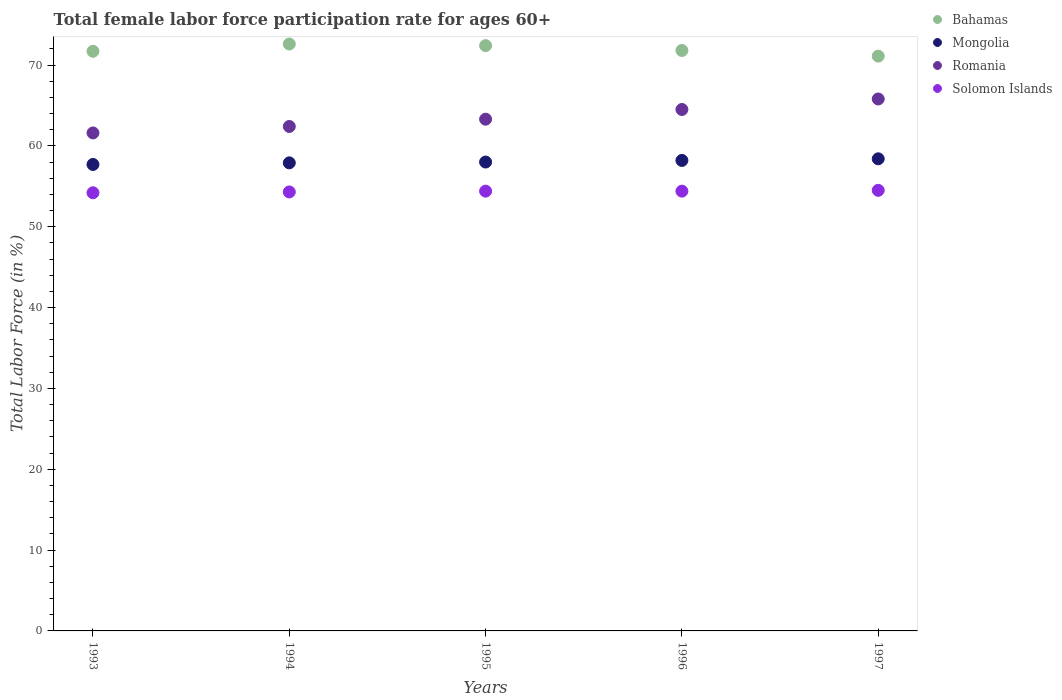How many different coloured dotlines are there?
Keep it short and to the point. 4. What is the female labor force participation rate in Mongolia in 1994?
Your answer should be compact. 57.9. Across all years, what is the maximum female labor force participation rate in Mongolia?
Offer a terse response. 58.4. Across all years, what is the minimum female labor force participation rate in Romania?
Your answer should be very brief. 61.6. What is the total female labor force participation rate in Solomon Islands in the graph?
Ensure brevity in your answer.  271.8. What is the difference between the female labor force participation rate in Romania in 1994 and that in 1997?
Your answer should be very brief. -3.4. What is the difference between the female labor force participation rate in Bahamas in 1994 and the female labor force participation rate in Solomon Islands in 1996?
Ensure brevity in your answer.  18.2. What is the average female labor force participation rate in Romania per year?
Provide a succinct answer. 63.52. In the year 1993, what is the difference between the female labor force participation rate in Romania and female labor force participation rate in Bahamas?
Provide a succinct answer. -10.1. In how many years, is the female labor force participation rate in Mongolia greater than 60 %?
Give a very brief answer. 0. What is the ratio of the female labor force participation rate in Mongolia in 1994 to that in 1995?
Keep it short and to the point. 1. Is the female labor force participation rate in Bahamas in 1993 less than that in 1994?
Give a very brief answer. Yes. Is the difference between the female labor force participation rate in Romania in 1996 and 1997 greater than the difference between the female labor force participation rate in Bahamas in 1996 and 1997?
Keep it short and to the point. No. What is the difference between the highest and the second highest female labor force participation rate in Mongolia?
Provide a succinct answer. 0.2. What is the difference between the highest and the lowest female labor force participation rate in Solomon Islands?
Keep it short and to the point. 0.3. Is the sum of the female labor force participation rate in Bahamas in 1993 and 1996 greater than the maximum female labor force participation rate in Mongolia across all years?
Make the answer very short. Yes. Is it the case that in every year, the sum of the female labor force participation rate in Solomon Islands and female labor force participation rate in Romania  is greater than the sum of female labor force participation rate in Mongolia and female labor force participation rate in Bahamas?
Make the answer very short. No. Is it the case that in every year, the sum of the female labor force participation rate in Bahamas and female labor force participation rate in Romania  is greater than the female labor force participation rate in Solomon Islands?
Your response must be concise. Yes. Does the female labor force participation rate in Solomon Islands monotonically increase over the years?
Keep it short and to the point. No. How many years are there in the graph?
Your answer should be compact. 5. What is the difference between two consecutive major ticks on the Y-axis?
Your response must be concise. 10. Does the graph contain grids?
Your answer should be very brief. No. Where does the legend appear in the graph?
Provide a succinct answer. Top right. How are the legend labels stacked?
Ensure brevity in your answer.  Vertical. What is the title of the graph?
Offer a very short reply. Total female labor force participation rate for ages 60+. Does "Ireland" appear as one of the legend labels in the graph?
Keep it short and to the point. No. What is the label or title of the Y-axis?
Offer a very short reply. Total Labor Force (in %). What is the Total Labor Force (in %) in Bahamas in 1993?
Give a very brief answer. 71.7. What is the Total Labor Force (in %) of Mongolia in 1993?
Offer a very short reply. 57.7. What is the Total Labor Force (in %) of Romania in 1993?
Provide a short and direct response. 61.6. What is the Total Labor Force (in %) in Solomon Islands in 1993?
Offer a terse response. 54.2. What is the Total Labor Force (in %) of Bahamas in 1994?
Make the answer very short. 72.6. What is the Total Labor Force (in %) in Mongolia in 1994?
Make the answer very short. 57.9. What is the Total Labor Force (in %) of Romania in 1994?
Ensure brevity in your answer.  62.4. What is the Total Labor Force (in %) in Solomon Islands in 1994?
Offer a very short reply. 54.3. What is the Total Labor Force (in %) of Bahamas in 1995?
Make the answer very short. 72.4. What is the Total Labor Force (in %) in Romania in 1995?
Give a very brief answer. 63.3. What is the Total Labor Force (in %) of Solomon Islands in 1995?
Offer a terse response. 54.4. What is the Total Labor Force (in %) of Bahamas in 1996?
Your response must be concise. 71.8. What is the Total Labor Force (in %) in Mongolia in 1996?
Your response must be concise. 58.2. What is the Total Labor Force (in %) in Romania in 1996?
Offer a terse response. 64.5. What is the Total Labor Force (in %) in Solomon Islands in 1996?
Offer a terse response. 54.4. What is the Total Labor Force (in %) in Bahamas in 1997?
Your answer should be very brief. 71.1. What is the Total Labor Force (in %) of Mongolia in 1997?
Keep it short and to the point. 58.4. What is the Total Labor Force (in %) of Romania in 1997?
Provide a short and direct response. 65.8. What is the Total Labor Force (in %) in Solomon Islands in 1997?
Make the answer very short. 54.5. Across all years, what is the maximum Total Labor Force (in %) of Bahamas?
Provide a succinct answer. 72.6. Across all years, what is the maximum Total Labor Force (in %) of Mongolia?
Your answer should be compact. 58.4. Across all years, what is the maximum Total Labor Force (in %) of Romania?
Your response must be concise. 65.8. Across all years, what is the maximum Total Labor Force (in %) of Solomon Islands?
Keep it short and to the point. 54.5. Across all years, what is the minimum Total Labor Force (in %) in Bahamas?
Give a very brief answer. 71.1. Across all years, what is the minimum Total Labor Force (in %) in Mongolia?
Your response must be concise. 57.7. Across all years, what is the minimum Total Labor Force (in %) of Romania?
Your response must be concise. 61.6. Across all years, what is the minimum Total Labor Force (in %) in Solomon Islands?
Offer a very short reply. 54.2. What is the total Total Labor Force (in %) of Bahamas in the graph?
Ensure brevity in your answer.  359.6. What is the total Total Labor Force (in %) in Mongolia in the graph?
Provide a succinct answer. 290.2. What is the total Total Labor Force (in %) in Romania in the graph?
Your answer should be compact. 317.6. What is the total Total Labor Force (in %) in Solomon Islands in the graph?
Your response must be concise. 271.8. What is the difference between the Total Labor Force (in %) of Romania in 1993 and that in 1994?
Your response must be concise. -0.8. What is the difference between the Total Labor Force (in %) of Bahamas in 1993 and that in 1995?
Offer a very short reply. -0.7. What is the difference between the Total Labor Force (in %) in Mongolia in 1993 and that in 1995?
Offer a very short reply. -0.3. What is the difference between the Total Labor Force (in %) of Romania in 1993 and that in 1995?
Keep it short and to the point. -1.7. What is the difference between the Total Labor Force (in %) of Solomon Islands in 1993 and that in 1995?
Offer a very short reply. -0.2. What is the difference between the Total Labor Force (in %) of Mongolia in 1993 and that in 1996?
Provide a short and direct response. -0.5. What is the difference between the Total Labor Force (in %) of Romania in 1993 and that in 1996?
Ensure brevity in your answer.  -2.9. What is the difference between the Total Labor Force (in %) in Solomon Islands in 1993 and that in 1996?
Make the answer very short. -0.2. What is the difference between the Total Labor Force (in %) of Bahamas in 1994 and that in 1995?
Offer a very short reply. 0.2. What is the difference between the Total Labor Force (in %) in Mongolia in 1994 and that in 1995?
Keep it short and to the point. -0.1. What is the difference between the Total Labor Force (in %) in Romania in 1994 and that in 1995?
Provide a short and direct response. -0.9. What is the difference between the Total Labor Force (in %) in Romania in 1994 and that in 1996?
Make the answer very short. -2.1. What is the difference between the Total Labor Force (in %) in Bahamas in 1994 and that in 1997?
Your response must be concise. 1.5. What is the difference between the Total Labor Force (in %) of Mongolia in 1994 and that in 1997?
Give a very brief answer. -0.5. What is the difference between the Total Labor Force (in %) of Romania in 1994 and that in 1997?
Your answer should be very brief. -3.4. What is the difference between the Total Labor Force (in %) of Solomon Islands in 1994 and that in 1997?
Make the answer very short. -0.2. What is the difference between the Total Labor Force (in %) in Bahamas in 1995 and that in 1996?
Your answer should be compact. 0.6. What is the difference between the Total Labor Force (in %) in Mongolia in 1995 and that in 1996?
Offer a terse response. -0.2. What is the difference between the Total Labor Force (in %) of Romania in 1995 and that in 1996?
Your response must be concise. -1.2. What is the difference between the Total Labor Force (in %) of Bahamas in 1996 and that in 1997?
Provide a short and direct response. 0.7. What is the difference between the Total Labor Force (in %) of Solomon Islands in 1996 and that in 1997?
Offer a terse response. -0.1. What is the difference between the Total Labor Force (in %) of Bahamas in 1993 and the Total Labor Force (in %) of Mongolia in 1994?
Make the answer very short. 13.8. What is the difference between the Total Labor Force (in %) in Bahamas in 1993 and the Total Labor Force (in %) in Romania in 1994?
Keep it short and to the point. 9.3. What is the difference between the Total Labor Force (in %) of Bahamas in 1993 and the Total Labor Force (in %) of Solomon Islands in 1994?
Make the answer very short. 17.4. What is the difference between the Total Labor Force (in %) in Mongolia in 1993 and the Total Labor Force (in %) in Solomon Islands in 1994?
Offer a very short reply. 3.4. What is the difference between the Total Labor Force (in %) in Romania in 1993 and the Total Labor Force (in %) in Solomon Islands in 1994?
Give a very brief answer. 7.3. What is the difference between the Total Labor Force (in %) in Bahamas in 1993 and the Total Labor Force (in %) in Romania in 1995?
Keep it short and to the point. 8.4. What is the difference between the Total Labor Force (in %) of Bahamas in 1993 and the Total Labor Force (in %) of Solomon Islands in 1995?
Your answer should be very brief. 17.3. What is the difference between the Total Labor Force (in %) of Mongolia in 1993 and the Total Labor Force (in %) of Romania in 1995?
Your response must be concise. -5.6. What is the difference between the Total Labor Force (in %) of Romania in 1993 and the Total Labor Force (in %) of Solomon Islands in 1995?
Ensure brevity in your answer.  7.2. What is the difference between the Total Labor Force (in %) in Bahamas in 1993 and the Total Labor Force (in %) in Mongolia in 1996?
Your answer should be compact. 13.5. What is the difference between the Total Labor Force (in %) in Bahamas in 1993 and the Total Labor Force (in %) in Romania in 1996?
Your answer should be very brief. 7.2. What is the difference between the Total Labor Force (in %) of Bahamas in 1993 and the Total Labor Force (in %) of Solomon Islands in 1996?
Keep it short and to the point. 17.3. What is the difference between the Total Labor Force (in %) of Mongolia in 1993 and the Total Labor Force (in %) of Romania in 1996?
Provide a succinct answer. -6.8. What is the difference between the Total Labor Force (in %) of Romania in 1993 and the Total Labor Force (in %) of Solomon Islands in 1996?
Ensure brevity in your answer.  7.2. What is the difference between the Total Labor Force (in %) of Bahamas in 1993 and the Total Labor Force (in %) of Mongolia in 1997?
Your answer should be compact. 13.3. What is the difference between the Total Labor Force (in %) in Bahamas in 1993 and the Total Labor Force (in %) in Romania in 1997?
Provide a succinct answer. 5.9. What is the difference between the Total Labor Force (in %) of Romania in 1993 and the Total Labor Force (in %) of Solomon Islands in 1997?
Your answer should be compact. 7.1. What is the difference between the Total Labor Force (in %) of Bahamas in 1994 and the Total Labor Force (in %) of Mongolia in 1995?
Make the answer very short. 14.6. What is the difference between the Total Labor Force (in %) in Mongolia in 1994 and the Total Labor Force (in %) in Romania in 1995?
Offer a terse response. -5.4. What is the difference between the Total Labor Force (in %) in Bahamas in 1994 and the Total Labor Force (in %) in Mongolia in 1996?
Your answer should be very brief. 14.4. What is the difference between the Total Labor Force (in %) of Bahamas in 1994 and the Total Labor Force (in %) of Romania in 1996?
Your response must be concise. 8.1. What is the difference between the Total Labor Force (in %) in Bahamas in 1994 and the Total Labor Force (in %) in Solomon Islands in 1996?
Your response must be concise. 18.2. What is the difference between the Total Labor Force (in %) of Mongolia in 1994 and the Total Labor Force (in %) of Romania in 1996?
Ensure brevity in your answer.  -6.6. What is the difference between the Total Labor Force (in %) in Romania in 1994 and the Total Labor Force (in %) in Solomon Islands in 1996?
Keep it short and to the point. 8. What is the difference between the Total Labor Force (in %) of Bahamas in 1994 and the Total Labor Force (in %) of Mongolia in 1997?
Provide a short and direct response. 14.2. What is the difference between the Total Labor Force (in %) in Bahamas in 1994 and the Total Labor Force (in %) in Solomon Islands in 1997?
Ensure brevity in your answer.  18.1. What is the difference between the Total Labor Force (in %) of Mongolia in 1994 and the Total Labor Force (in %) of Solomon Islands in 1997?
Your answer should be compact. 3.4. What is the difference between the Total Labor Force (in %) in Bahamas in 1995 and the Total Labor Force (in %) in Romania in 1996?
Keep it short and to the point. 7.9. What is the difference between the Total Labor Force (in %) of Mongolia in 1995 and the Total Labor Force (in %) of Solomon Islands in 1996?
Ensure brevity in your answer.  3.6. What is the difference between the Total Labor Force (in %) of Mongolia in 1995 and the Total Labor Force (in %) of Romania in 1997?
Give a very brief answer. -7.8. What is the difference between the Total Labor Force (in %) in Romania in 1995 and the Total Labor Force (in %) in Solomon Islands in 1997?
Your response must be concise. 8.8. What is the difference between the Total Labor Force (in %) in Bahamas in 1996 and the Total Labor Force (in %) in Mongolia in 1997?
Your answer should be very brief. 13.4. What is the difference between the Total Labor Force (in %) in Mongolia in 1996 and the Total Labor Force (in %) in Solomon Islands in 1997?
Make the answer very short. 3.7. What is the difference between the Total Labor Force (in %) in Romania in 1996 and the Total Labor Force (in %) in Solomon Islands in 1997?
Ensure brevity in your answer.  10. What is the average Total Labor Force (in %) of Bahamas per year?
Offer a terse response. 71.92. What is the average Total Labor Force (in %) in Mongolia per year?
Your answer should be very brief. 58.04. What is the average Total Labor Force (in %) in Romania per year?
Provide a succinct answer. 63.52. What is the average Total Labor Force (in %) of Solomon Islands per year?
Provide a succinct answer. 54.36. In the year 1993, what is the difference between the Total Labor Force (in %) of Bahamas and Total Labor Force (in %) of Romania?
Keep it short and to the point. 10.1. In the year 1993, what is the difference between the Total Labor Force (in %) in Mongolia and Total Labor Force (in %) in Solomon Islands?
Keep it short and to the point. 3.5. In the year 1994, what is the difference between the Total Labor Force (in %) in Bahamas and Total Labor Force (in %) in Solomon Islands?
Provide a succinct answer. 18.3. In the year 1994, what is the difference between the Total Labor Force (in %) in Mongolia and Total Labor Force (in %) in Romania?
Your response must be concise. -4.5. In the year 1994, what is the difference between the Total Labor Force (in %) in Mongolia and Total Labor Force (in %) in Solomon Islands?
Offer a terse response. 3.6. In the year 1995, what is the difference between the Total Labor Force (in %) in Bahamas and Total Labor Force (in %) in Solomon Islands?
Provide a succinct answer. 18. In the year 1995, what is the difference between the Total Labor Force (in %) of Romania and Total Labor Force (in %) of Solomon Islands?
Ensure brevity in your answer.  8.9. In the year 1996, what is the difference between the Total Labor Force (in %) in Bahamas and Total Labor Force (in %) in Mongolia?
Your response must be concise. 13.6. In the year 1996, what is the difference between the Total Labor Force (in %) of Bahamas and Total Labor Force (in %) of Solomon Islands?
Provide a short and direct response. 17.4. In the year 1996, what is the difference between the Total Labor Force (in %) in Mongolia and Total Labor Force (in %) in Romania?
Your response must be concise. -6.3. In the year 1996, what is the difference between the Total Labor Force (in %) of Mongolia and Total Labor Force (in %) of Solomon Islands?
Provide a short and direct response. 3.8. In the year 1997, what is the difference between the Total Labor Force (in %) of Romania and Total Labor Force (in %) of Solomon Islands?
Give a very brief answer. 11.3. What is the ratio of the Total Labor Force (in %) of Bahamas in 1993 to that in 1994?
Provide a short and direct response. 0.99. What is the ratio of the Total Labor Force (in %) of Romania in 1993 to that in 1994?
Your response must be concise. 0.99. What is the ratio of the Total Labor Force (in %) in Bahamas in 1993 to that in 1995?
Offer a very short reply. 0.99. What is the ratio of the Total Labor Force (in %) of Romania in 1993 to that in 1995?
Keep it short and to the point. 0.97. What is the ratio of the Total Labor Force (in %) in Solomon Islands in 1993 to that in 1995?
Your answer should be very brief. 1. What is the ratio of the Total Labor Force (in %) in Bahamas in 1993 to that in 1996?
Make the answer very short. 1. What is the ratio of the Total Labor Force (in %) of Romania in 1993 to that in 1996?
Keep it short and to the point. 0.95. What is the ratio of the Total Labor Force (in %) in Bahamas in 1993 to that in 1997?
Offer a very short reply. 1.01. What is the ratio of the Total Labor Force (in %) in Romania in 1993 to that in 1997?
Offer a terse response. 0.94. What is the ratio of the Total Labor Force (in %) in Bahamas in 1994 to that in 1995?
Your answer should be compact. 1. What is the ratio of the Total Labor Force (in %) in Romania in 1994 to that in 1995?
Keep it short and to the point. 0.99. What is the ratio of the Total Labor Force (in %) in Bahamas in 1994 to that in 1996?
Provide a short and direct response. 1.01. What is the ratio of the Total Labor Force (in %) in Mongolia in 1994 to that in 1996?
Offer a very short reply. 0.99. What is the ratio of the Total Labor Force (in %) in Romania in 1994 to that in 1996?
Offer a terse response. 0.97. What is the ratio of the Total Labor Force (in %) of Bahamas in 1994 to that in 1997?
Make the answer very short. 1.02. What is the ratio of the Total Labor Force (in %) of Mongolia in 1994 to that in 1997?
Make the answer very short. 0.99. What is the ratio of the Total Labor Force (in %) of Romania in 1994 to that in 1997?
Your answer should be compact. 0.95. What is the ratio of the Total Labor Force (in %) in Bahamas in 1995 to that in 1996?
Your response must be concise. 1.01. What is the ratio of the Total Labor Force (in %) in Mongolia in 1995 to that in 1996?
Offer a very short reply. 1. What is the ratio of the Total Labor Force (in %) of Romania in 1995 to that in 1996?
Offer a terse response. 0.98. What is the ratio of the Total Labor Force (in %) in Bahamas in 1995 to that in 1997?
Give a very brief answer. 1.02. What is the ratio of the Total Labor Force (in %) of Mongolia in 1995 to that in 1997?
Offer a terse response. 0.99. What is the ratio of the Total Labor Force (in %) in Romania in 1995 to that in 1997?
Your answer should be very brief. 0.96. What is the ratio of the Total Labor Force (in %) in Bahamas in 1996 to that in 1997?
Ensure brevity in your answer.  1.01. What is the ratio of the Total Labor Force (in %) in Romania in 1996 to that in 1997?
Your answer should be compact. 0.98. What is the difference between the highest and the second highest Total Labor Force (in %) of Mongolia?
Give a very brief answer. 0.2. What is the difference between the highest and the second highest Total Labor Force (in %) in Romania?
Make the answer very short. 1.3. What is the difference between the highest and the lowest Total Labor Force (in %) of Solomon Islands?
Give a very brief answer. 0.3. 